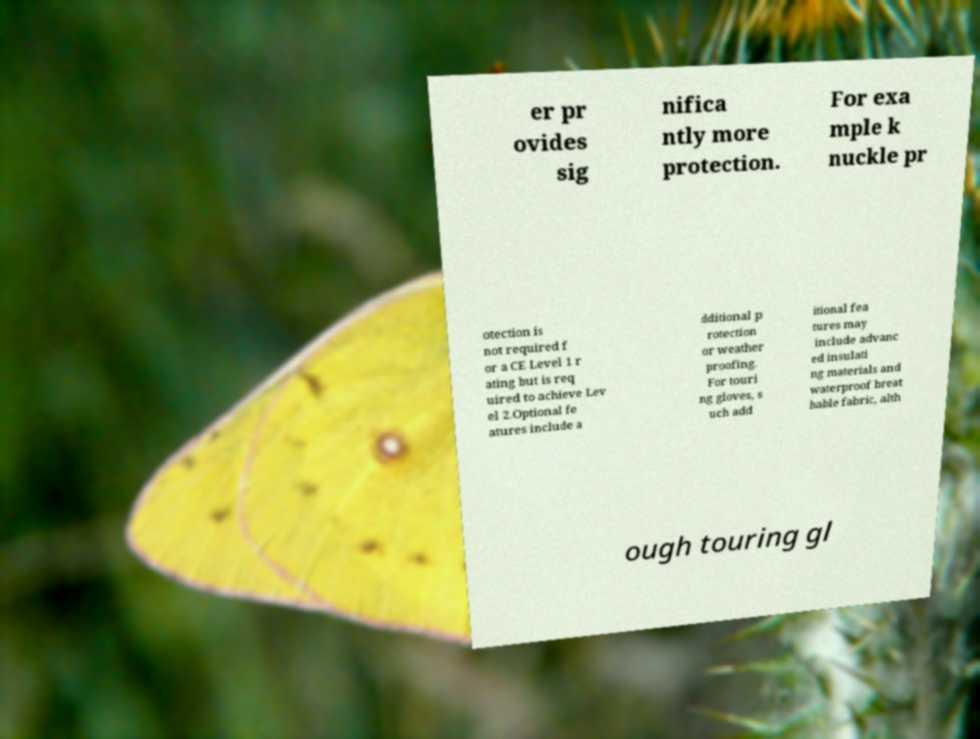There's text embedded in this image that I need extracted. Can you transcribe it verbatim? er pr ovides sig nifica ntly more protection. For exa mple k nuckle pr otection is not required f or a CE Level 1 r ating but is req uired to achieve Lev el 2.Optional fe atures include a dditional p rotection or weather proofing. For touri ng gloves, s uch add itional fea tures may include advanc ed insulati ng materials and waterproof breat hable fabric, alth ough touring gl 